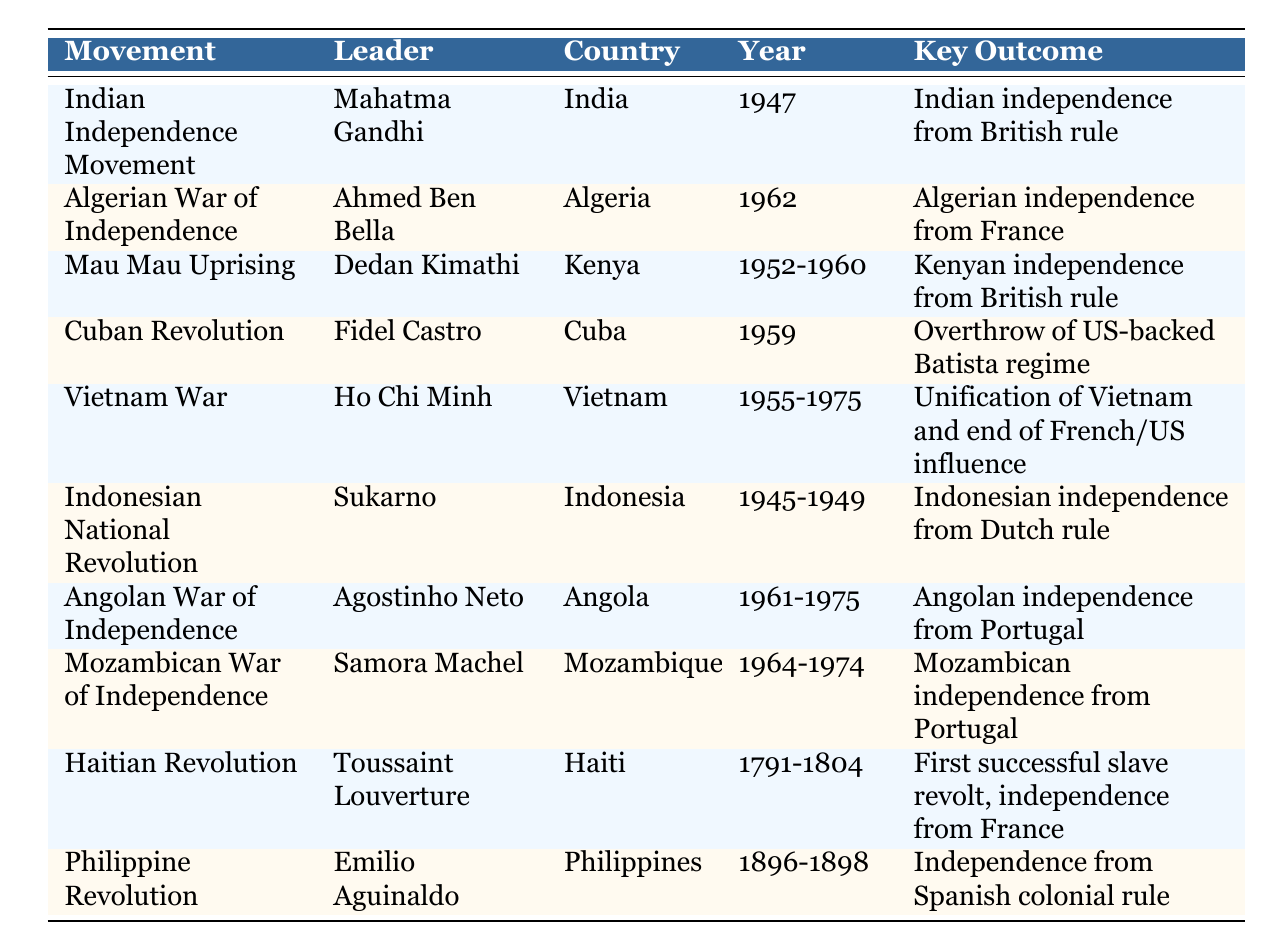What country did Mahatma Gandhi lead the independence movement in? The table lists the Indian Independence Movement under the "Movement" column and shows Mahatma Gandhi as the leader. The corresponding country in the table is India.
Answer: India Which leader fought for independence from British rule in Kenya? The table shows the "Mau Mau Uprising" under the "Movement" column with Dedan Kimathi listed as the leader for Kenya.
Answer: Dedan Kimathi Was the Cuban Revolution aimed at overthrowing a US-backed regime? The table indicates that the "Cuban Revolution" was led by Fidel Castro, and the key outcome was the overthrow of the US-backed Batista regime. Therefore, the statement is true.
Answer: Yes How many movements were aimed at gaining independence from Portugal? The table lists the "Angolan War of Independence" and the "Mozambican War of Independence," both of which were aimed at gaining independence from Portugal. This shows there are two such movements.
Answer: 2 Which anti-colonial movement occurred first, the Haitian Revolution or the Philippine Revolution? By checking the years listed in the table, the Haitian Revolution spans from 1791 to 1804, while the Philippine Revolution occurred from 1896 to 1898. Thus, the Haitian Revolution took place first.
Answer: Haitian Revolution What was the key outcome of the Indonesian National Revolution? The table states that the key outcome of the Indonesian National Revolution, led by Sukarno from 1945 to 1949, was Indonesian independence from Dutch rule. This matches the information in the "Key Outcome" column associated with that movement.
Answer: Indonesian independence from Dutch rule Which leader's efforts led to the unification of Vietnam? According to the table, Ho Chi Minh led the Vietnam War, which resulted in the unification of Vietnam and the end of French/US influence. This indicates that Ho Chi Minh's efforts were instrumental in achieving this outcome.
Answer: Ho Chi Minh In which year did Algeria gain independence? The table clearly indicates that Algeria gained independence in 1962, as listed under the "Year" column for the "Algerian War of Independence."
Answer: 1962 What is the average time span of the movements listed in the table? To find the average time span, we need to calculate the duration for each listed movement: Indian Independence Movement (1 year), Algerian War of Independence (1 year), Mau Mau Uprising (9 years), Cuban Revolution (1 year), Vietnam War (20 years), Indonesian National Revolution (4 years), Angolan War of Independence (15 years), Mozambican War of Independence (10 years), and the other movements (Haitian Revolution and Philippine Revolution) span over several years. Adding all durations together gives 1 + 1 + 9 + 1 + 20 + 4 + 15 + 10 + 13 + 2 = 76 years. There are 10 movements listed, so, the average is 76/10 = 7.6 years.
Answer: 7.6 years What were the key outcomes of the Mau Mau Uprising? The table specifies that the key outcome of the Mau Mau Uprising was Kenyan independence from British rule, which can be directly referenced from the "Key Outcome" column of that specific movement.
Answer: Kenyan independence from British rule 